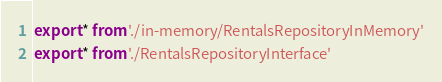Convert code to text. <code><loc_0><loc_0><loc_500><loc_500><_TypeScript_>export * from './in-memory/RentalsRepositoryInMemory'
export * from './RentalsRepositoryInterface'
</code> 